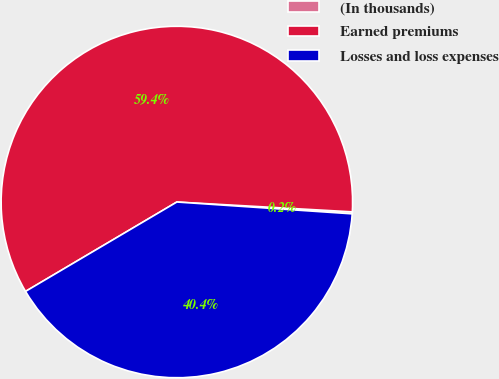Convert chart to OTSL. <chart><loc_0><loc_0><loc_500><loc_500><pie_chart><fcel>(In thousands)<fcel>Earned premiums<fcel>Losses and loss expenses<nl><fcel>0.18%<fcel>59.39%<fcel>40.44%<nl></chart> 